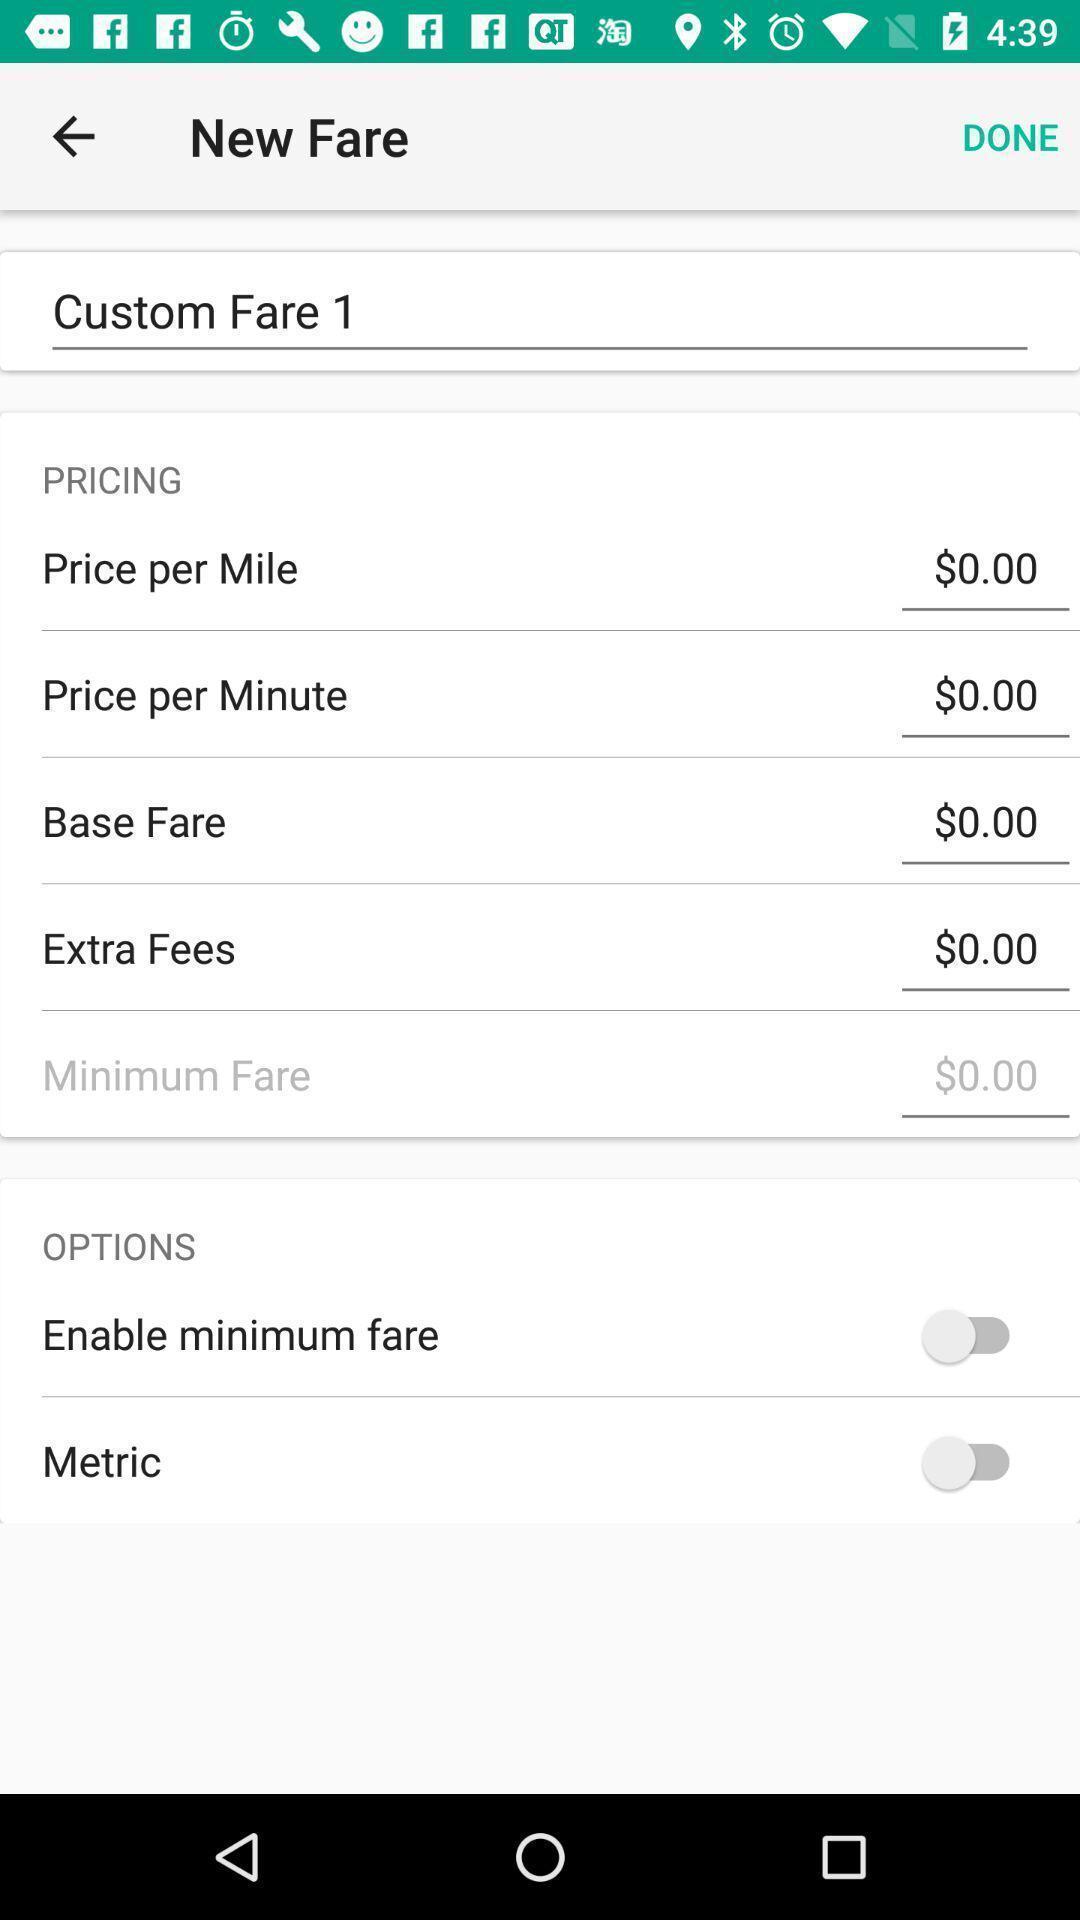Please provide a description for this image. Screen shows about new fare. 